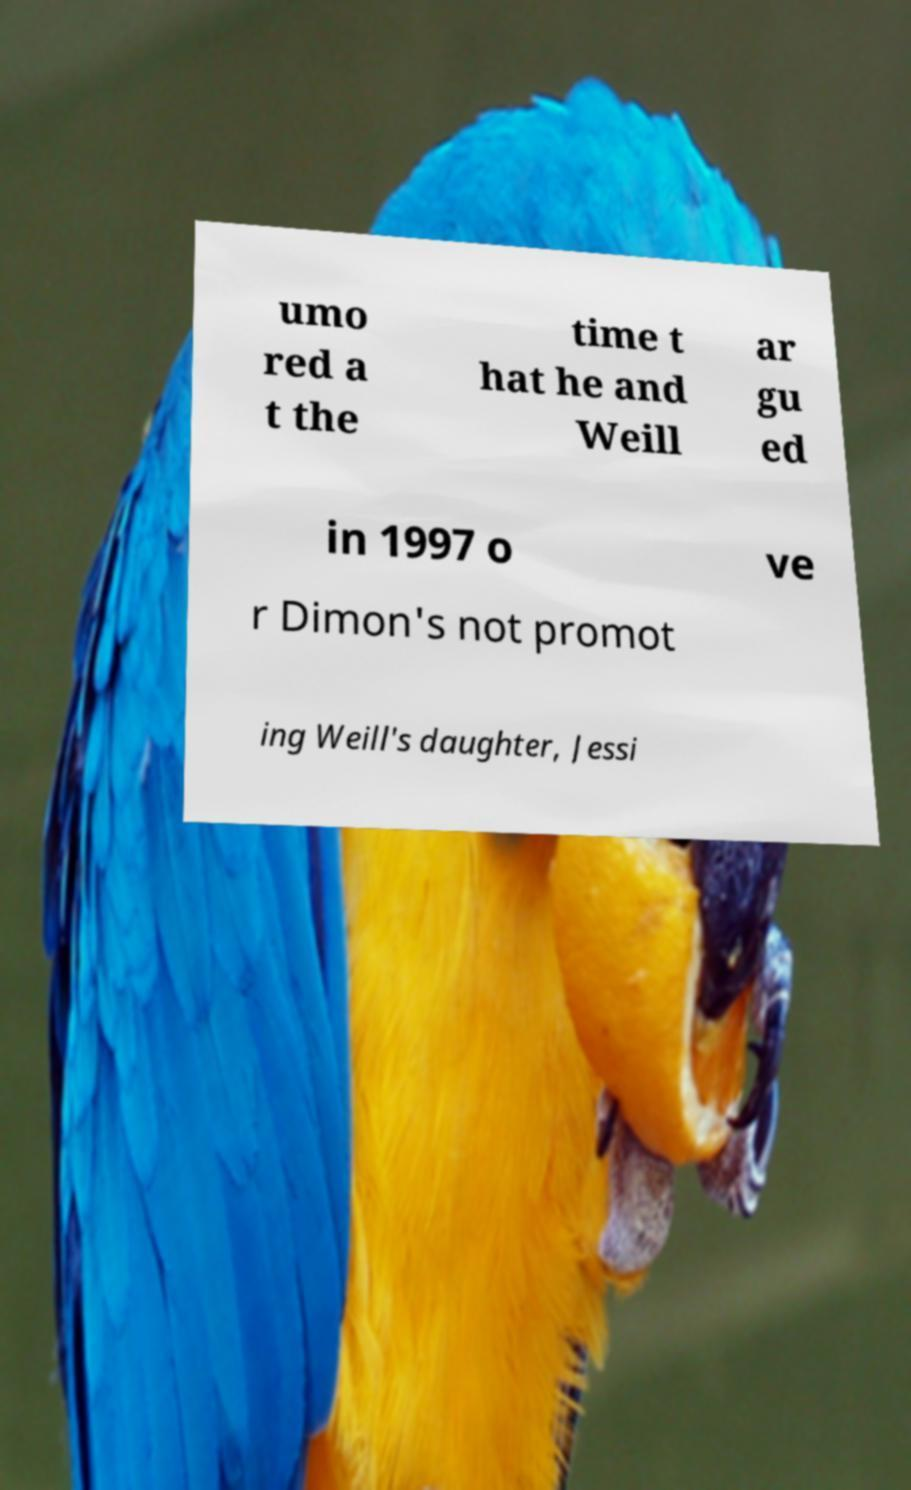Could you assist in decoding the text presented in this image and type it out clearly? umo red a t the time t hat he and Weill ar gu ed in 1997 o ve r Dimon's not promot ing Weill's daughter, Jessi 